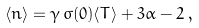<formula> <loc_0><loc_0><loc_500><loc_500>\langle n \rangle = \gamma \, \sigma ( 0 ) \langle T \rangle + 3 \alpha - 2 \, ,</formula> 